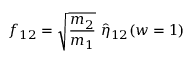<formula> <loc_0><loc_0><loc_500><loc_500>f _ { 1 2 } = \sqrt { \frac { m _ { 2 } } { m _ { 1 } } } \ \hat { \eta } _ { 1 2 } ( w = 1 )</formula> 